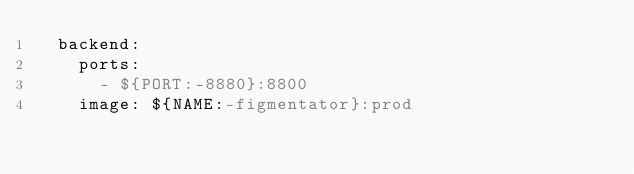Convert code to text. <code><loc_0><loc_0><loc_500><loc_500><_YAML_>  backend:
    ports:
      - ${PORT:-8880}:8800
    image: ${NAME:-figmentator}:prod
</code> 